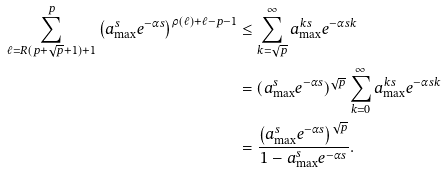Convert formula to latex. <formula><loc_0><loc_0><loc_500><loc_500>\sum _ { \ell = R ( p + \sqrt { p } + 1 ) + 1 } ^ { p } \left ( a _ { \max } ^ { s } e ^ { - \alpha s } \right ) ^ { \rho ( \ell ) + \ell - p - 1 } & \leq \sum _ { k = \sqrt { p } } ^ { \infty } a _ { \max } ^ { k s } e ^ { - \alpha s k } \\ & = ( a _ { \max } ^ { s } e ^ { - \alpha s } ) ^ { \sqrt { p } } \sum _ { k = 0 } ^ { \infty } { a _ { \max } ^ { k s } e ^ { - \alpha s k } } \\ & = \frac { \left ( a _ { \max } ^ { s } e ^ { - \alpha s } \right ) ^ { \sqrt { p } } } { 1 - a _ { \max } ^ { s } e ^ { - \alpha s } } .</formula> 